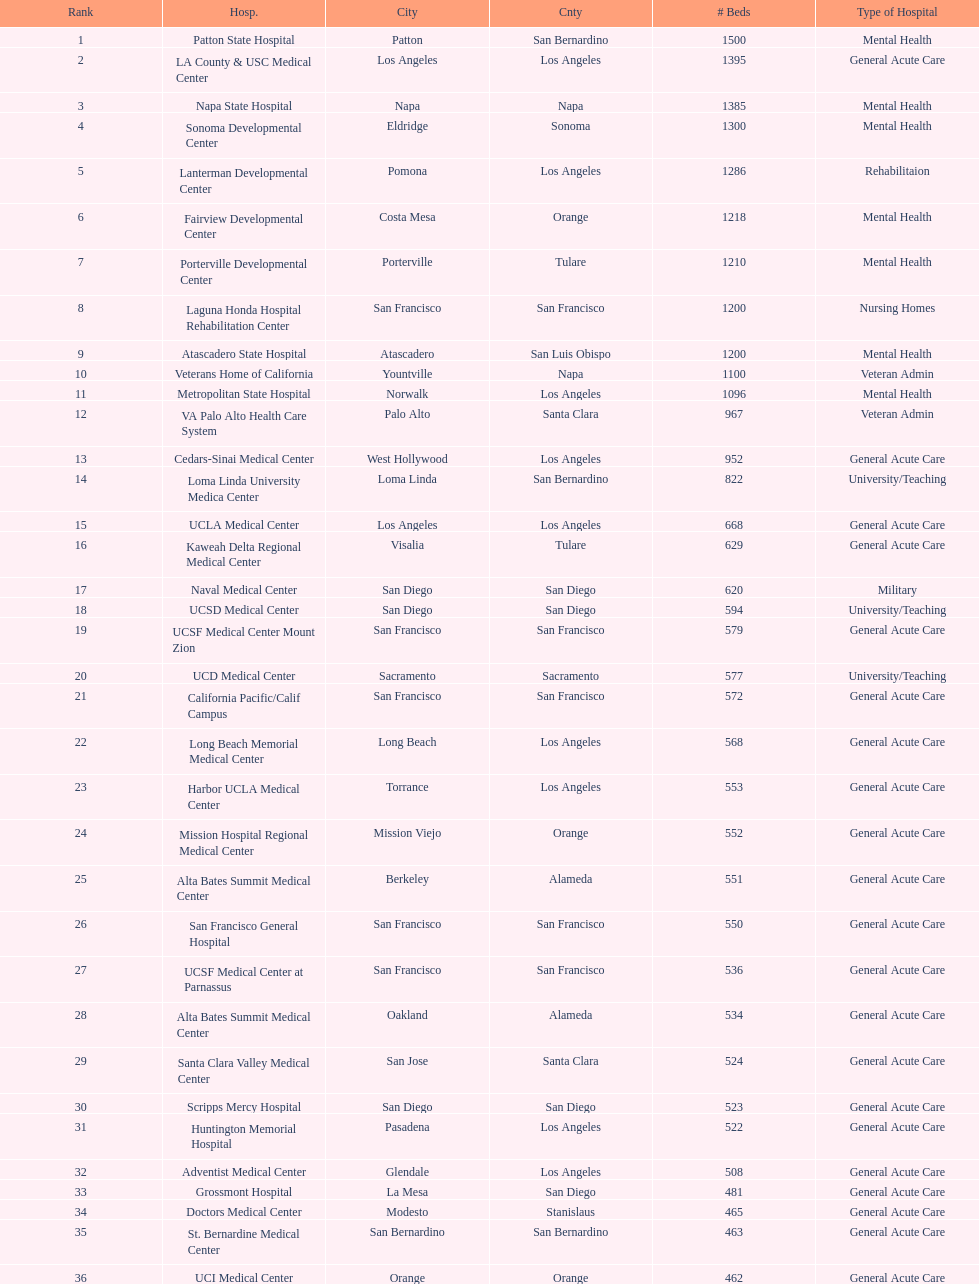What two hospitals holding consecutive rankings of 8 and 9 respectively, both provide 1200 hospital beds? Laguna Honda Hospital Rehabilitation Center, Atascadero State Hospital. 